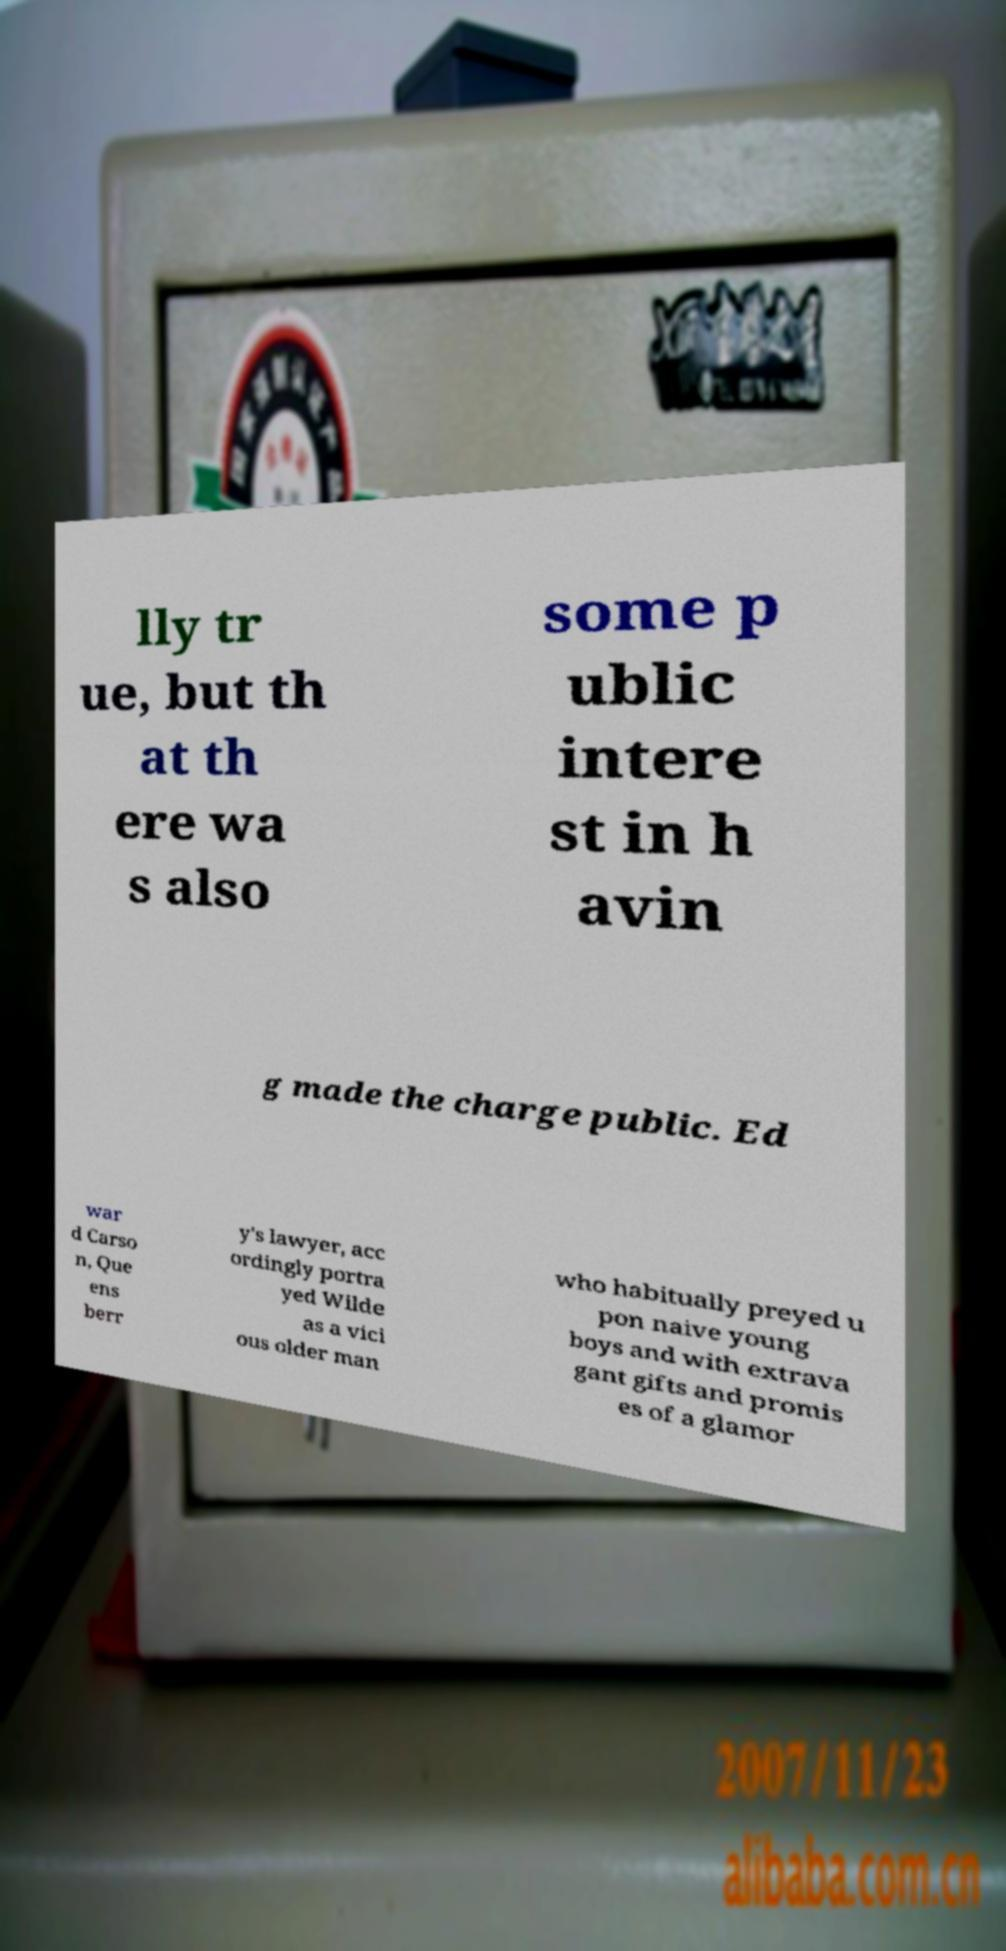Can you read and provide the text displayed in the image?This photo seems to have some interesting text. Can you extract and type it out for me? lly tr ue, but th at th ere wa s also some p ublic intere st in h avin g made the charge public. Ed war d Carso n, Que ens berr y's lawyer, acc ordingly portra yed Wilde as a vici ous older man who habitually preyed u pon naive young boys and with extrava gant gifts and promis es of a glamor 